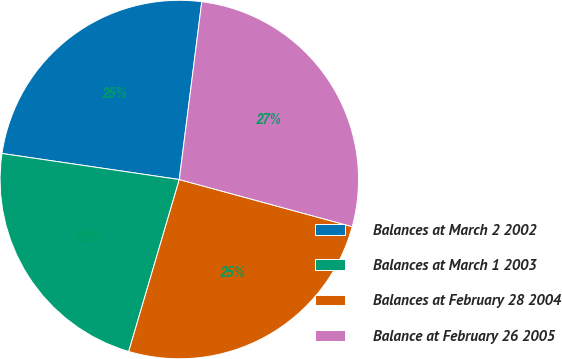<chart> <loc_0><loc_0><loc_500><loc_500><pie_chart><fcel>Balances at March 2 2002<fcel>Balances at March 1 2003<fcel>Balances at February 28 2004<fcel>Balance at February 26 2005<nl><fcel>24.68%<fcel>22.77%<fcel>25.32%<fcel>27.23%<nl></chart> 